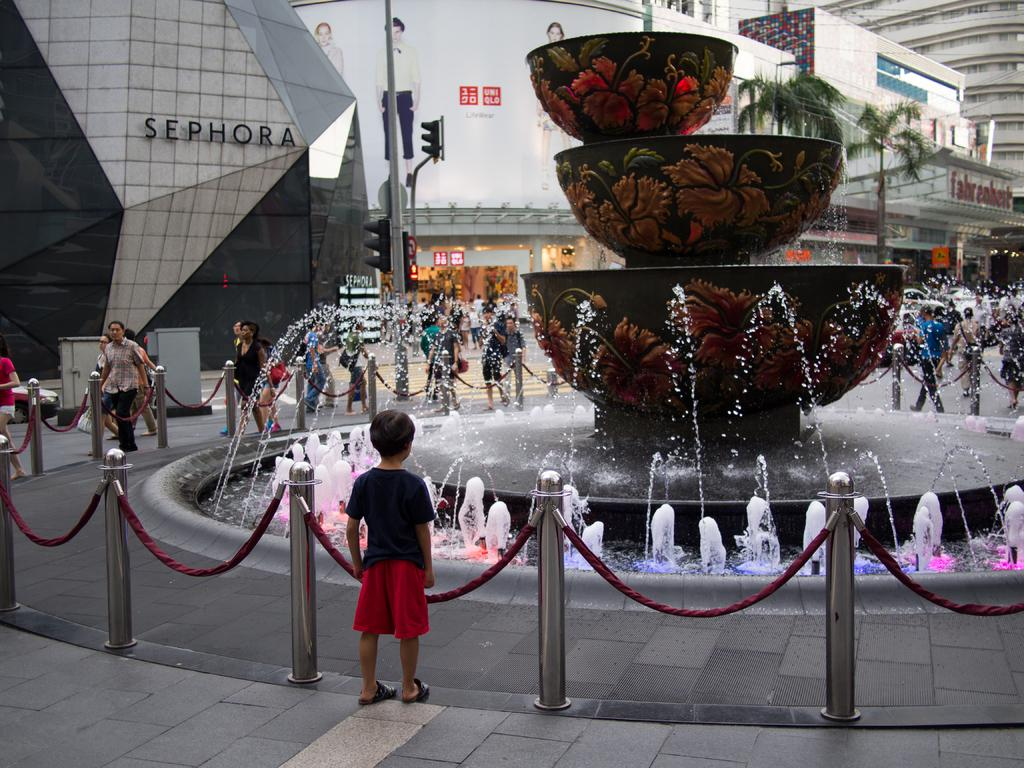Provide a one-sentence caption for the provided image. A young boy stares at a fountain outside a Sephora store. 